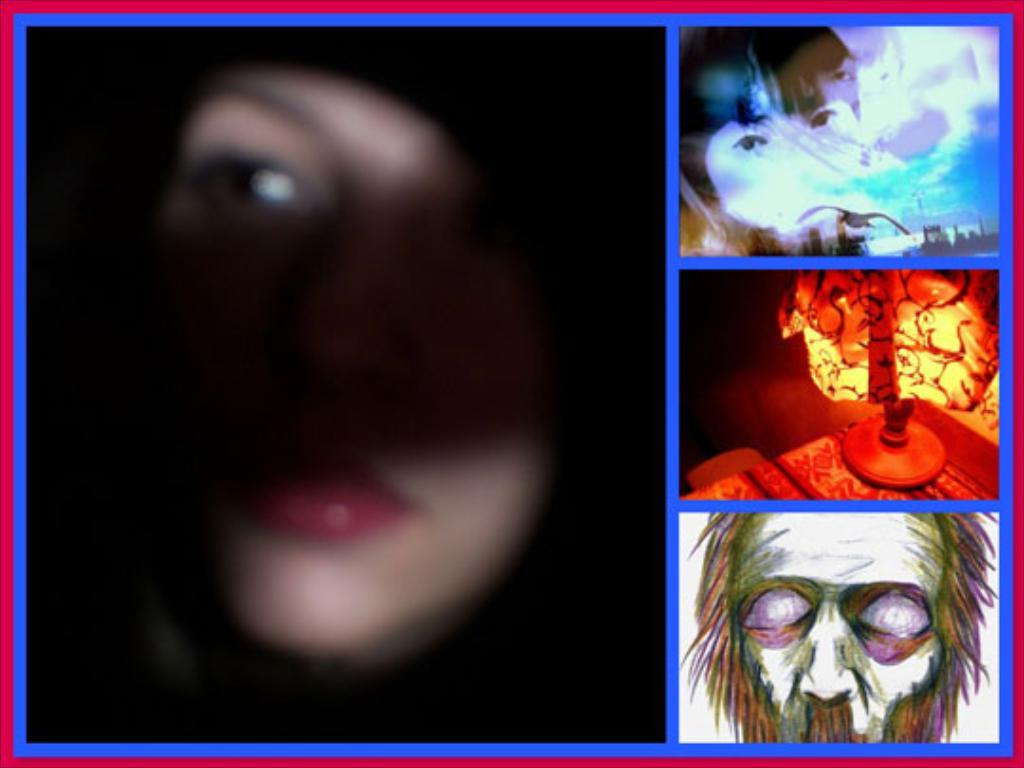What is the main subject of the image? The image contains a collage of photos. Can you describe the face on the left side of the collage? There is a face of a person on the left side of the collage. What type of pictures can be seen on the right side of the collage? There are depiction pictures on the right side of the collage. What other elements are present in the middle of the collage? There are other elements in the middle of the collage. What type of throat can be seen in the image? There is no throat present in the image; it contains a collage of photos. Is there a hole visible in the image? There is no hole visible in the image; it contains a collage of photos. 